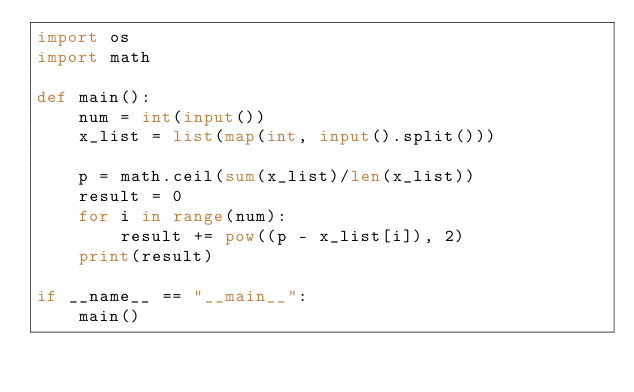<code> <loc_0><loc_0><loc_500><loc_500><_Python_>import os
import math

def main():
    num = int(input())
    x_list = list(map(int, input().split()))

    p = math.ceil(sum(x_list)/len(x_list))
    result = 0
    for i in range(num):
        result += pow((p - x_list[i]), 2)
    print(result)

if __name__ == "__main__":
    main()</code> 